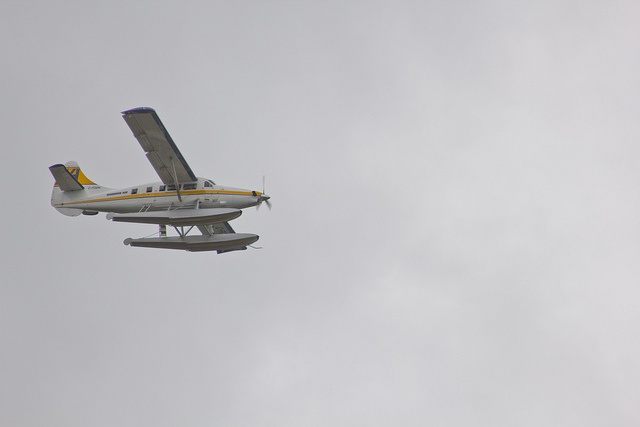Describe the objects in this image and their specific colors. I can see a airplane in darkgray, gray, black, and olive tones in this image. 